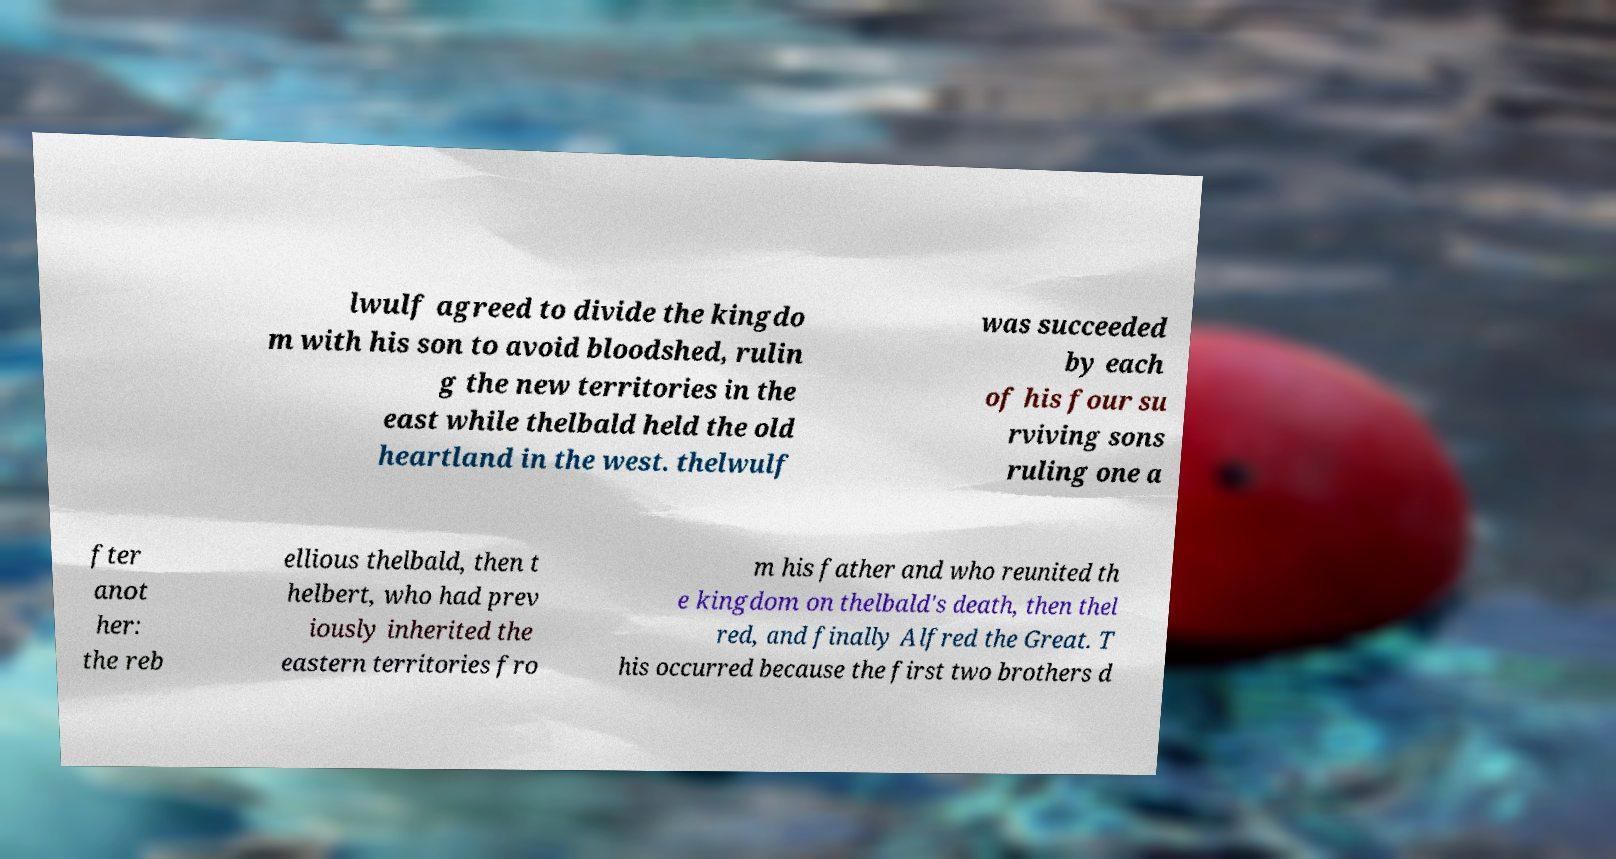Can you accurately transcribe the text from the provided image for me? lwulf agreed to divide the kingdo m with his son to avoid bloodshed, rulin g the new territories in the east while thelbald held the old heartland in the west. thelwulf was succeeded by each of his four su rviving sons ruling one a fter anot her: the reb ellious thelbald, then t helbert, who had prev iously inherited the eastern territories fro m his father and who reunited th e kingdom on thelbald's death, then thel red, and finally Alfred the Great. T his occurred because the first two brothers d 